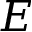Convert formula to latex. <formula><loc_0><loc_0><loc_500><loc_500>E</formula> 